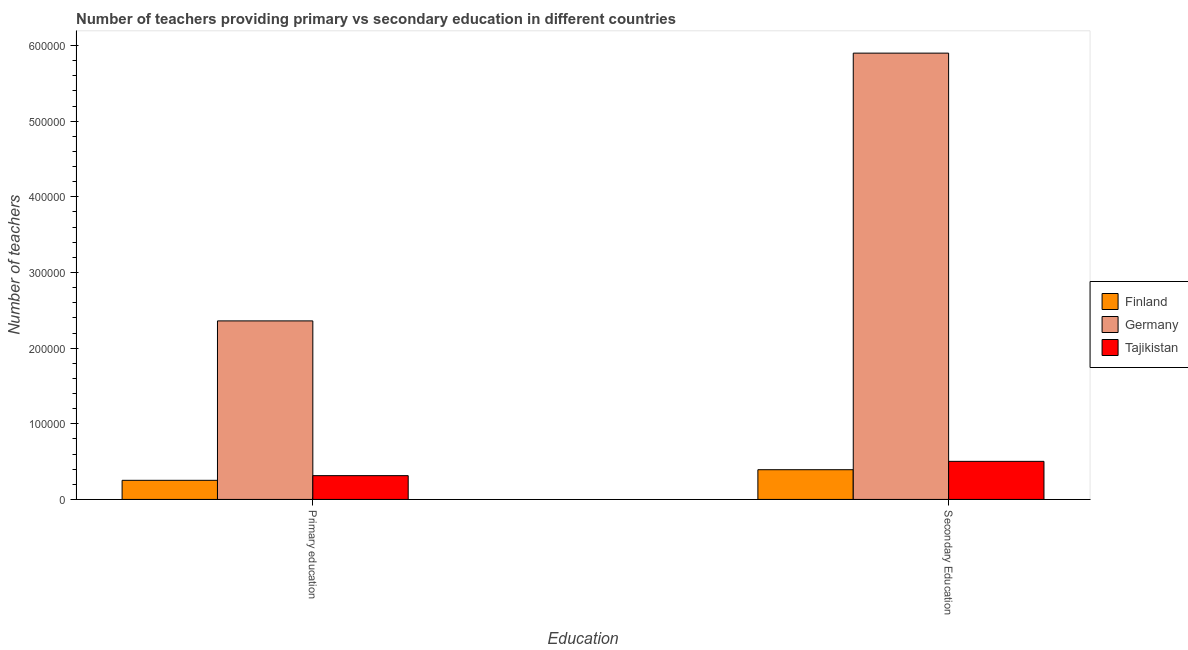How many bars are there on the 2nd tick from the right?
Your answer should be very brief. 3. What is the label of the 2nd group of bars from the left?
Offer a terse response. Secondary Education. What is the number of secondary teachers in Finland?
Your answer should be compact. 3.93e+04. Across all countries, what is the maximum number of primary teachers?
Provide a short and direct response. 2.36e+05. Across all countries, what is the minimum number of primary teachers?
Your answer should be very brief. 2.53e+04. In which country was the number of primary teachers minimum?
Offer a terse response. Finland. What is the total number of secondary teachers in the graph?
Give a very brief answer. 6.80e+05. What is the difference between the number of primary teachers in Germany and that in Finland?
Your answer should be very brief. 2.11e+05. What is the difference between the number of secondary teachers in Finland and the number of primary teachers in Tajikistan?
Your answer should be very brief. 7853. What is the average number of secondary teachers per country?
Make the answer very short. 2.27e+05. What is the difference between the number of primary teachers and number of secondary teachers in Finland?
Your answer should be compact. -1.40e+04. In how many countries, is the number of secondary teachers greater than 60000 ?
Make the answer very short. 1. What is the ratio of the number of secondary teachers in Germany to that in Finland?
Ensure brevity in your answer.  15.02. Is the number of secondary teachers in Tajikistan less than that in Finland?
Your response must be concise. No. In how many countries, is the number of primary teachers greater than the average number of primary teachers taken over all countries?
Keep it short and to the point. 1. What does the 2nd bar from the right in Secondary Education represents?
Provide a succinct answer. Germany. How many countries are there in the graph?
Ensure brevity in your answer.  3. What is the difference between two consecutive major ticks on the Y-axis?
Ensure brevity in your answer.  1.00e+05. Are the values on the major ticks of Y-axis written in scientific E-notation?
Keep it short and to the point. No. Does the graph contain any zero values?
Keep it short and to the point. No. How are the legend labels stacked?
Provide a succinct answer. Vertical. What is the title of the graph?
Offer a very short reply. Number of teachers providing primary vs secondary education in different countries. What is the label or title of the X-axis?
Offer a terse response. Education. What is the label or title of the Y-axis?
Ensure brevity in your answer.  Number of teachers. What is the Number of teachers of Finland in Primary education?
Your answer should be very brief. 2.53e+04. What is the Number of teachers in Germany in Primary education?
Provide a succinct answer. 2.36e+05. What is the Number of teachers of Tajikistan in Primary education?
Provide a short and direct response. 3.14e+04. What is the Number of teachers of Finland in Secondary Education?
Keep it short and to the point. 3.93e+04. What is the Number of teachers in Germany in Secondary Education?
Your response must be concise. 5.90e+05. What is the Number of teachers of Tajikistan in Secondary Education?
Your response must be concise. 5.03e+04. Across all Education, what is the maximum Number of teachers of Finland?
Your answer should be very brief. 3.93e+04. Across all Education, what is the maximum Number of teachers of Germany?
Keep it short and to the point. 5.90e+05. Across all Education, what is the maximum Number of teachers of Tajikistan?
Give a very brief answer. 5.03e+04. Across all Education, what is the minimum Number of teachers of Finland?
Offer a very short reply. 2.53e+04. Across all Education, what is the minimum Number of teachers in Germany?
Your response must be concise. 2.36e+05. Across all Education, what is the minimum Number of teachers in Tajikistan?
Keep it short and to the point. 3.14e+04. What is the total Number of teachers in Finland in the graph?
Your answer should be very brief. 6.45e+04. What is the total Number of teachers in Germany in the graph?
Provide a succinct answer. 8.26e+05. What is the total Number of teachers of Tajikistan in the graph?
Your answer should be compact. 8.18e+04. What is the difference between the Number of teachers of Finland in Primary education and that in Secondary Education?
Provide a short and direct response. -1.40e+04. What is the difference between the Number of teachers in Germany in Primary education and that in Secondary Education?
Your response must be concise. -3.54e+05. What is the difference between the Number of teachers of Tajikistan in Primary education and that in Secondary Education?
Offer a very short reply. -1.89e+04. What is the difference between the Number of teachers in Finland in Primary education and the Number of teachers in Germany in Secondary Education?
Your answer should be very brief. -5.65e+05. What is the difference between the Number of teachers of Finland in Primary education and the Number of teachers of Tajikistan in Secondary Education?
Your answer should be compact. -2.51e+04. What is the difference between the Number of teachers in Germany in Primary education and the Number of teachers in Tajikistan in Secondary Education?
Ensure brevity in your answer.  1.86e+05. What is the average Number of teachers of Finland per Education?
Offer a terse response. 3.23e+04. What is the average Number of teachers of Germany per Education?
Your answer should be very brief. 4.13e+05. What is the average Number of teachers in Tajikistan per Education?
Provide a short and direct response. 4.09e+04. What is the difference between the Number of teachers in Finland and Number of teachers in Germany in Primary education?
Your answer should be very brief. -2.11e+05. What is the difference between the Number of teachers in Finland and Number of teachers in Tajikistan in Primary education?
Offer a terse response. -6163. What is the difference between the Number of teachers of Germany and Number of teachers of Tajikistan in Primary education?
Your response must be concise. 2.05e+05. What is the difference between the Number of teachers of Finland and Number of teachers of Germany in Secondary Education?
Provide a short and direct response. -5.51e+05. What is the difference between the Number of teachers of Finland and Number of teachers of Tajikistan in Secondary Education?
Provide a short and direct response. -1.11e+04. What is the difference between the Number of teachers of Germany and Number of teachers of Tajikistan in Secondary Education?
Your answer should be very brief. 5.40e+05. What is the ratio of the Number of teachers of Finland in Primary education to that in Secondary Education?
Give a very brief answer. 0.64. What is the ratio of the Number of teachers of Tajikistan in Primary education to that in Secondary Education?
Offer a terse response. 0.62. What is the difference between the highest and the second highest Number of teachers in Finland?
Your answer should be very brief. 1.40e+04. What is the difference between the highest and the second highest Number of teachers in Germany?
Ensure brevity in your answer.  3.54e+05. What is the difference between the highest and the second highest Number of teachers in Tajikistan?
Your answer should be very brief. 1.89e+04. What is the difference between the highest and the lowest Number of teachers of Finland?
Provide a short and direct response. 1.40e+04. What is the difference between the highest and the lowest Number of teachers of Germany?
Offer a very short reply. 3.54e+05. What is the difference between the highest and the lowest Number of teachers of Tajikistan?
Your response must be concise. 1.89e+04. 